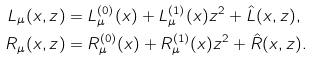Convert formula to latex. <formula><loc_0><loc_0><loc_500><loc_500>L _ { \mu } ( x , z ) & = L ^ { ( 0 ) } _ { \mu } ( x ) + L ^ { ( 1 ) } _ { \mu } ( x ) z ^ { 2 } + { \hat { L } } ( x , z ) , \\ R _ { \mu } ( x , z ) & = R ^ { ( 0 ) } _ { \mu } ( x ) + R ^ { ( 1 ) } _ { \mu } ( x ) z ^ { 2 } + { \hat { R } } ( x , z ) .</formula> 